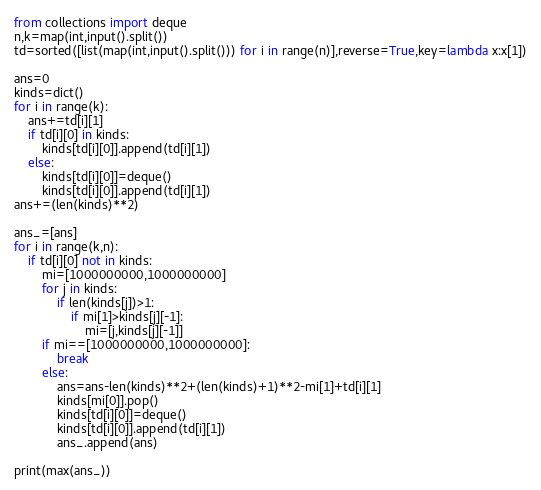<code> <loc_0><loc_0><loc_500><loc_500><_Python_>from collections import deque
n,k=map(int,input().split())
td=sorted([list(map(int,input().split())) for i in range(n)],reverse=True,key=lambda x:x[1])

ans=0
kinds=dict()
for i in range(k):
    ans+=td[i][1]
    if td[i][0] in kinds:
        kinds[td[i][0]].append(td[i][1])
    else:
        kinds[td[i][0]]=deque()
        kinds[td[i][0]].append(td[i][1])
ans+=(len(kinds)**2)

ans_=[ans]
for i in range(k,n):
    if td[i][0] not in kinds:
        mi=[1000000000,1000000000]
        for j in kinds:
            if len(kinds[j])>1:
                if mi[1]>kinds[j][-1]:
                    mi=[j,kinds[j][-1]]
        if mi==[1000000000,1000000000]:
            break
        else:
            ans=ans-len(kinds)**2+(len(kinds)+1)**2-mi[1]+td[i][1]
            kinds[mi[0]].pop()
            kinds[td[i][0]]=deque()
            kinds[td[i][0]].append(td[i][1])
            ans_.append(ans)

print(max(ans_))
</code> 